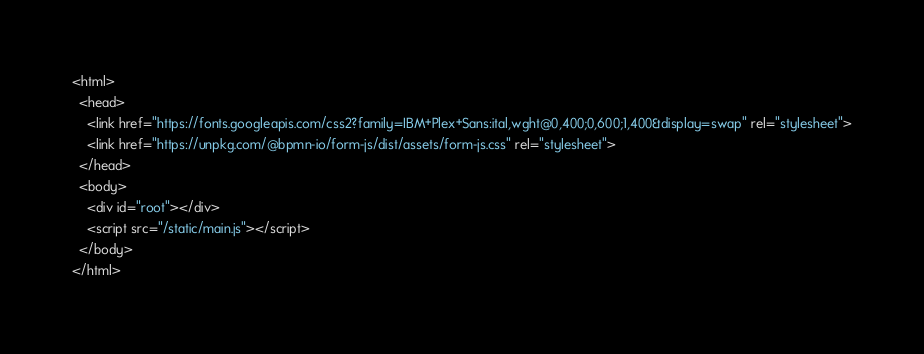Convert code to text. <code><loc_0><loc_0><loc_500><loc_500><_HTML_><html>
  <head>
    <link href="https://fonts.googleapis.com/css2?family=IBM+Plex+Sans:ital,wght@0,400;0,600;1,400&display=swap" rel="stylesheet">
    <link href="https://unpkg.com/@bpmn-io/form-js/dist/assets/form-js.css" rel="stylesheet">
  </head>
  <body>
    <div id="root"></div>
    <script src="/static/main.js"></script>
  </body>
</html>
</code> 